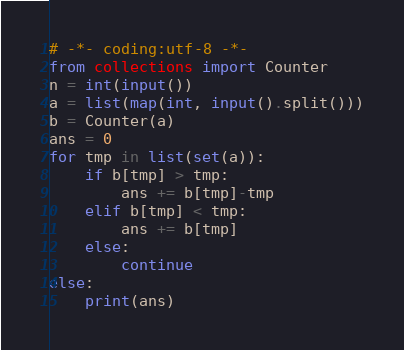Convert code to text. <code><loc_0><loc_0><loc_500><loc_500><_Python_># -*- coding:utf-8 -*-
from collections import Counter
n = int(input())
a = list(map(int, input().split()))
b = Counter(a)
ans = 0
for tmp in list(set(a)):
    if b[tmp] > tmp:
        ans += b[tmp]-tmp
    elif b[tmp] < tmp:
        ans += b[tmp]
    else:
        continue
else:
    print(ans)</code> 